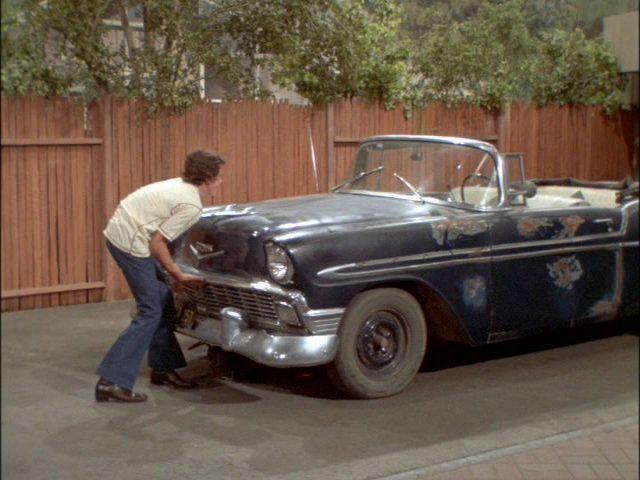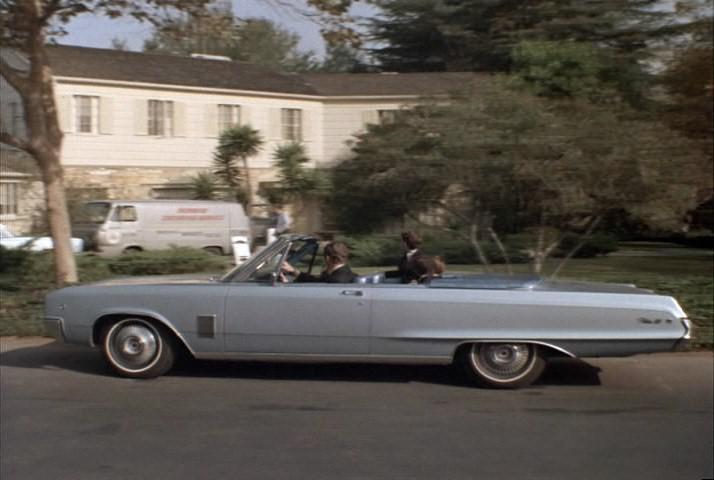The first image is the image on the left, the second image is the image on the right. Examine the images to the left and right. Is the description "An image shows at least two people in a blue convertible with the top down, next to a privacy fence." accurate? Answer yes or no. No. The first image is the image on the left, the second image is the image on the right. Evaluate the accuracy of this statement regarding the images: "In the right image, there is a blue convertible facing the right". Is it true? Answer yes or no. No. The first image is the image on the left, the second image is the image on the right. Assess this claim about the two images: "Two cars have convertible tops and have small wing windows beside the windshield.". Correct or not? Answer yes or no. Yes. The first image is the image on the left, the second image is the image on the right. Assess this claim about the two images: "There is one convertible driving down the road facing left.". Correct or not? Answer yes or no. Yes. The first image is the image on the left, the second image is the image on the right. For the images displayed, is the sentence "There is a convertible in each photo with it's top down" factually correct? Answer yes or no. Yes. 